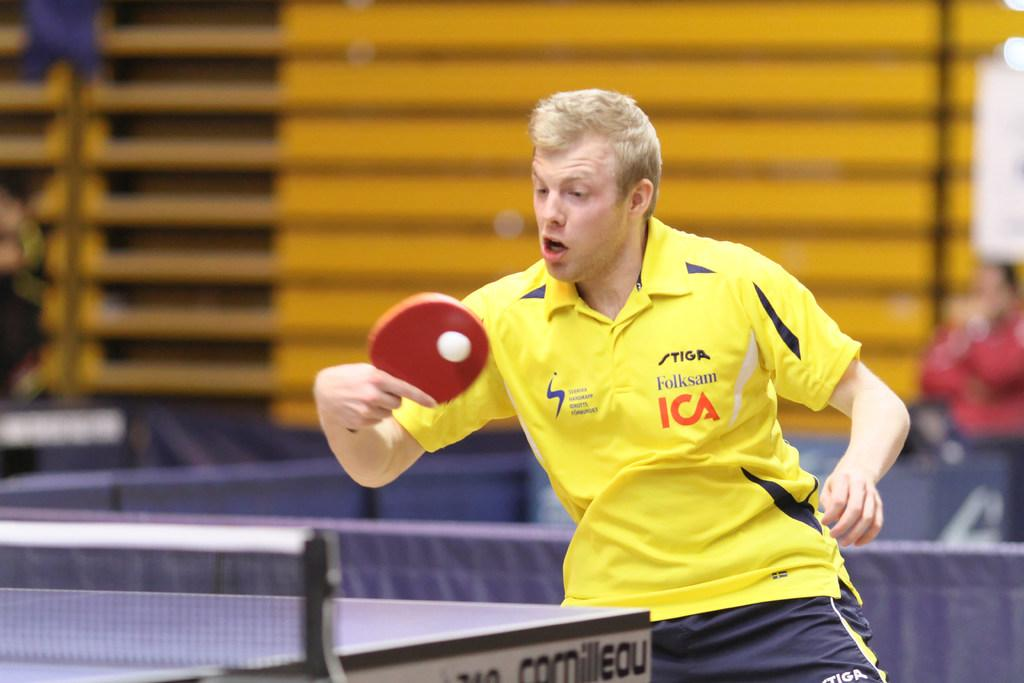What activity is the person in the image engaged in? The person is standing and playing table tennis. What object is the person holding while playing table tennis? The person is holding a bat. What sport is being played in the image? The game being played is table tennis. Are there any other people visible in the image? Yes, there are other persons visible in the background. Can you see the person's toes in the image? The image does not show the person's toes, as they are likely covered by their shoes or not visible due to the angle of the shot. 